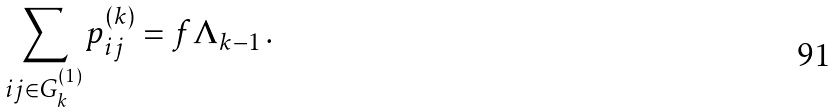Convert formula to latex. <formula><loc_0><loc_0><loc_500><loc_500>\sum _ { i j \in G _ { k } ^ { ( 1 ) } } p _ { i j } ^ { ( k ) } = f \Lambda _ { k - 1 } \, .</formula> 